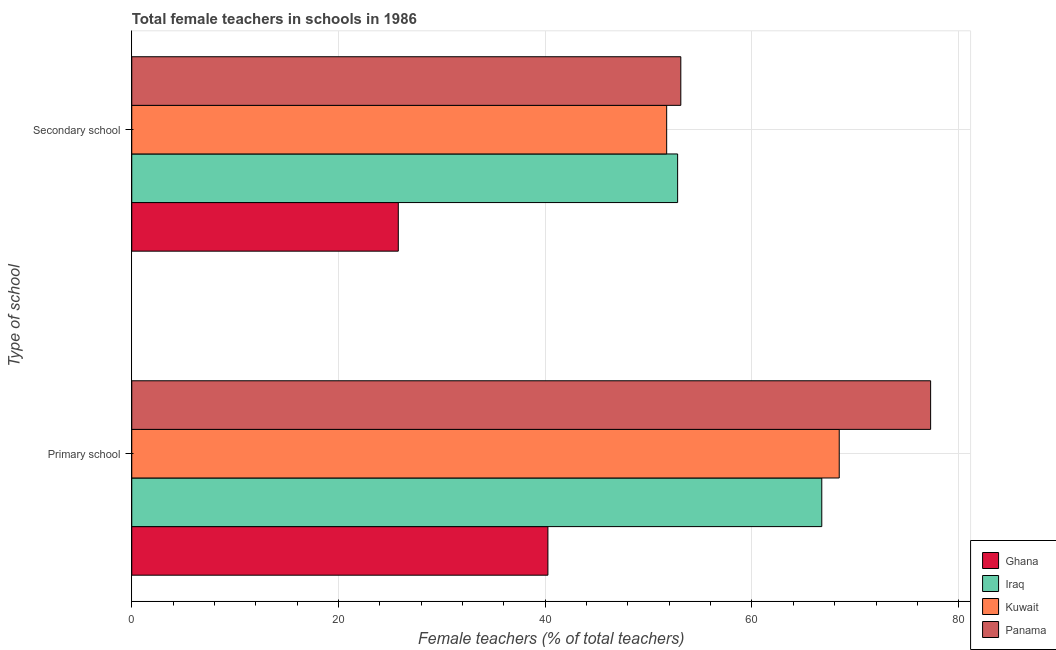Are the number of bars on each tick of the Y-axis equal?
Offer a terse response. Yes. How many bars are there on the 1st tick from the bottom?
Your answer should be very brief. 4. What is the label of the 2nd group of bars from the top?
Provide a succinct answer. Primary school. What is the percentage of female teachers in primary schools in Iraq?
Provide a short and direct response. 66.75. Across all countries, what is the maximum percentage of female teachers in primary schools?
Ensure brevity in your answer.  77.28. Across all countries, what is the minimum percentage of female teachers in primary schools?
Your answer should be very brief. 40.26. In which country was the percentage of female teachers in secondary schools maximum?
Keep it short and to the point. Panama. What is the total percentage of female teachers in primary schools in the graph?
Keep it short and to the point. 252.73. What is the difference between the percentage of female teachers in secondary schools in Ghana and that in Iraq?
Your answer should be compact. -27.02. What is the difference between the percentage of female teachers in primary schools in Panama and the percentage of female teachers in secondary schools in Kuwait?
Your response must be concise. 25.53. What is the average percentage of female teachers in primary schools per country?
Offer a very short reply. 63.18. What is the difference between the percentage of female teachers in primary schools and percentage of female teachers in secondary schools in Panama?
Offer a very short reply. 24.17. What is the ratio of the percentage of female teachers in primary schools in Ghana to that in Panama?
Offer a terse response. 0.52. What does the 3rd bar from the top in Secondary school represents?
Keep it short and to the point. Iraq. What does the 3rd bar from the bottom in Primary school represents?
Give a very brief answer. Kuwait. How many bars are there?
Provide a short and direct response. 8. How many countries are there in the graph?
Your answer should be compact. 4. What is the difference between two consecutive major ticks on the X-axis?
Provide a succinct answer. 20. Are the values on the major ticks of X-axis written in scientific E-notation?
Offer a terse response. No. Does the graph contain any zero values?
Your response must be concise. No. Where does the legend appear in the graph?
Your response must be concise. Bottom right. How are the legend labels stacked?
Ensure brevity in your answer.  Vertical. What is the title of the graph?
Your answer should be compact. Total female teachers in schools in 1986. Does "Angola" appear as one of the legend labels in the graph?
Offer a terse response. No. What is the label or title of the X-axis?
Your response must be concise. Female teachers (% of total teachers). What is the label or title of the Y-axis?
Your answer should be very brief. Type of school. What is the Female teachers (% of total teachers) in Ghana in Primary school?
Offer a very short reply. 40.26. What is the Female teachers (% of total teachers) in Iraq in Primary school?
Your response must be concise. 66.75. What is the Female teachers (% of total teachers) of Kuwait in Primary school?
Keep it short and to the point. 68.44. What is the Female teachers (% of total teachers) of Panama in Primary school?
Give a very brief answer. 77.28. What is the Female teachers (% of total teachers) of Ghana in Secondary school?
Your response must be concise. 25.78. What is the Female teachers (% of total teachers) in Iraq in Secondary school?
Offer a terse response. 52.81. What is the Female teachers (% of total teachers) in Kuwait in Secondary school?
Your answer should be compact. 51.75. What is the Female teachers (% of total teachers) in Panama in Secondary school?
Your answer should be compact. 53.11. Across all Type of school, what is the maximum Female teachers (% of total teachers) of Ghana?
Make the answer very short. 40.26. Across all Type of school, what is the maximum Female teachers (% of total teachers) in Iraq?
Provide a short and direct response. 66.75. Across all Type of school, what is the maximum Female teachers (% of total teachers) in Kuwait?
Your response must be concise. 68.44. Across all Type of school, what is the maximum Female teachers (% of total teachers) of Panama?
Provide a succinct answer. 77.28. Across all Type of school, what is the minimum Female teachers (% of total teachers) of Ghana?
Give a very brief answer. 25.78. Across all Type of school, what is the minimum Female teachers (% of total teachers) of Iraq?
Provide a succinct answer. 52.81. Across all Type of school, what is the minimum Female teachers (% of total teachers) of Kuwait?
Offer a terse response. 51.75. Across all Type of school, what is the minimum Female teachers (% of total teachers) of Panama?
Ensure brevity in your answer.  53.11. What is the total Female teachers (% of total teachers) of Ghana in the graph?
Ensure brevity in your answer.  66.04. What is the total Female teachers (% of total teachers) in Iraq in the graph?
Provide a short and direct response. 119.56. What is the total Female teachers (% of total teachers) of Kuwait in the graph?
Provide a short and direct response. 120.19. What is the total Female teachers (% of total teachers) of Panama in the graph?
Keep it short and to the point. 130.4. What is the difference between the Female teachers (% of total teachers) in Ghana in Primary school and that in Secondary school?
Ensure brevity in your answer.  14.47. What is the difference between the Female teachers (% of total teachers) of Iraq in Primary school and that in Secondary school?
Offer a very short reply. 13.95. What is the difference between the Female teachers (% of total teachers) of Kuwait in Primary school and that in Secondary school?
Your response must be concise. 16.69. What is the difference between the Female teachers (% of total teachers) in Panama in Primary school and that in Secondary school?
Your response must be concise. 24.17. What is the difference between the Female teachers (% of total teachers) of Ghana in Primary school and the Female teachers (% of total teachers) of Iraq in Secondary school?
Make the answer very short. -12.55. What is the difference between the Female teachers (% of total teachers) of Ghana in Primary school and the Female teachers (% of total teachers) of Kuwait in Secondary school?
Offer a very short reply. -11.49. What is the difference between the Female teachers (% of total teachers) in Ghana in Primary school and the Female teachers (% of total teachers) in Panama in Secondary school?
Make the answer very short. -12.86. What is the difference between the Female teachers (% of total teachers) of Iraq in Primary school and the Female teachers (% of total teachers) of Kuwait in Secondary school?
Ensure brevity in your answer.  15. What is the difference between the Female teachers (% of total teachers) in Iraq in Primary school and the Female teachers (% of total teachers) in Panama in Secondary school?
Provide a succinct answer. 13.64. What is the difference between the Female teachers (% of total teachers) in Kuwait in Primary school and the Female teachers (% of total teachers) in Panama in Secondary school?
Your answer should be very brief. 15.33. What is the average Female teachers (% of total teachers) in Ghana per Type of school?
Give a very brief answer. 33.02. What is the average Female teachers (% of total teachers) in Iraq per Type of school?
Give a very brief answer. 59.78. What is the average Female teachers (% of total teachers) in Kuwait per Type of school?
Make the answer very short. 60.09. What is the average Female teachers (% of total teachers) of Panama per Type of school?
Offer a terse response. 65.2. What is the difference between the Female teachers (% of total teachers) in Ghana and Female teachers (% of total teachers) in Iraq in Primary school?
Keep it short and to the point. -26.49. What is the difference between the Female teachers (% of total teachers) in Ghana and Female teachers (% of total teachers) in Kuwait in Primary school?
Provide a succinct answer. -28.18. What is the difference between the Female teachers (% of total teachers) in Ghana and Female teachers (% of total teachers) in Panama in Primary school?
Keep it short and to the point. -37.02. What is the difference between the Female teachers (% of total teachers) of Iraq and Female teachers (% of total teachers) of Kuwait in Primary school?
Offer a very short reply. -1.69. What is the difference between the Female teachers (% of total teachers) of Iraq and Female teachers (% of total teachers) of Panama in Primary school?
Your response must be concise. -10.53. What is the difference between the Female teachers (% of total teachers) of Kuwait and Female teachers (% of total teachers) of Panama in Primary school?
Your answer should be very brief. -8.84. What is the difference between the Female teachers (% of total teachers) in Ghana and Female teachers (% of total teachers) in Iraq in Secondary school?
Provide a short and direct response. -27.02. What is the difference between the Female teachers (% of total teachers) of Ghana and Female teachers (% of total teachers) of Kuwait in Secondary school?
Provide a short and direct response. -25.96. What is the difference between the Female teachers (% of total teachers) of Ghana and Female teachers (% of total teachers) of Panama in Secondary school?
Offer a very short reply. -27.33. What is the difference between the Female teachers (% of total teachers) of Iraq and Female teachers (% of total teachers) of Kuwait in Secondary school?
Make the answer very short. 1.06. What is the difference between the Female teachers (% of total teachers) in Iraq and Female teachers (% of total teachers) in Panama in Secondary school?
Ensure brevity in your answer.  -0.31. What is the difference between the Female teachers (% of total teachers) in Kuwait and Female teachers (% of total teachers) in Panama in Secondary school?
Provide a succinct answer. -1.37. What is the ratio of the Female teachers (% of total teachers) of Ghana in Primary school to that in Secondary school?
Provide a succinct answer. 1.56. What is the ratio of the Female teachers (% of total teachers) in Iraq in Primary school to that in Secondary school?
Provide a succinct answer. 1.26. What is the ratio of the Female teachers (% of total teachers) in Kuwait in Primary school to that in Secondary school?
Your answer should be very brief. 1.32. What is the ratio of the Female teachers (% of total teachers) in Panama in Primary school to that in Secondary school?
Provide a succinct answer. 1.46. What is the difference between the highest and the second highest Female teachers (% of total teachers) in Ghana?
Keep it short and to the point. 14.47. What is the difference between the highest and the second highest Female teachers (% of total teachers) of Iraq?
Give a very brief answer. 13.95. What is the difference between the highest and the second highest Female teachers (% of total teachers) in Kuwait?
Keep it short and to the point. 16.69. What is the difference between the highest and the second highest Female teachers (% of total teachers) of Panama?
Make the answer very short. 24.17. What is the difference between the highest and the lowest Female teachers (% of total teachers) in Ghana?
Ensure brevity in your answer.  14.47. What is the difference between the highest and the lowest Female teachers (% of total teachers) in Iraq?
Provide a succinct answer. 13.95. What is the difference between the highest and the lowest Female teachers (% of total teachers) of Kuwait?
Your response must be concise. 16.69. What is the difference between the highest and the lowest Female teachers (% of total teachers) in Panama?
Make the answer very short. 24.17. 